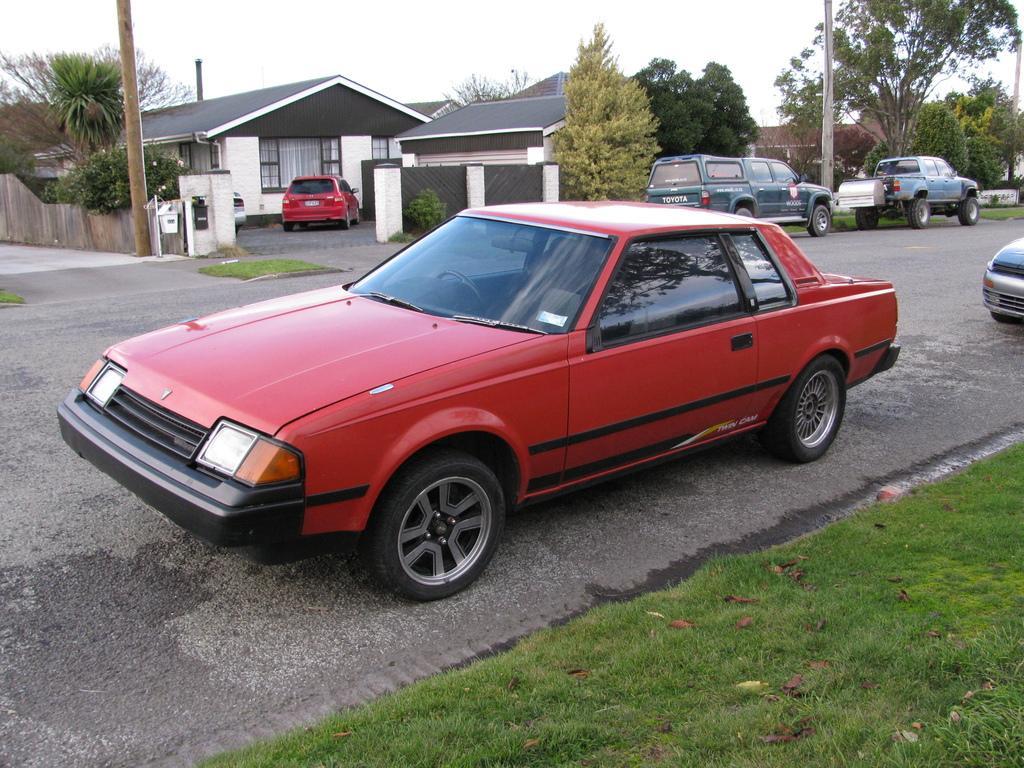Please provide a concise description of this image. In the picture I can see vehicles on the road. In the background I can houses, poles, fence, trees, the grass, plants, the sky and some other objects on the ground. 